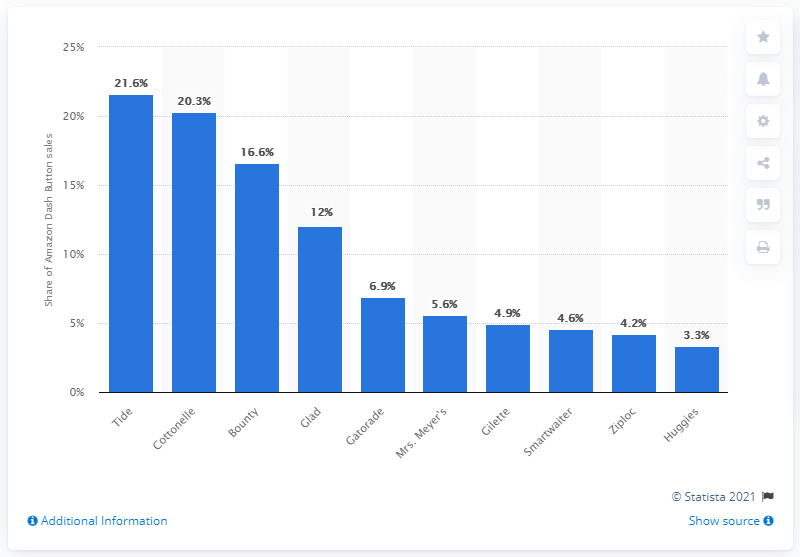Outline some significant characteristics in this image. According to the information presented, the second-ranked product in terms of sales share was Cottonelle with a 20.3% sales share. Tide was the brand that accounted for 21.6 percent of Dash buttons sold. 